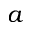<formula> <loc_0><loc_0><loc_500><loc_500>a</formula> 